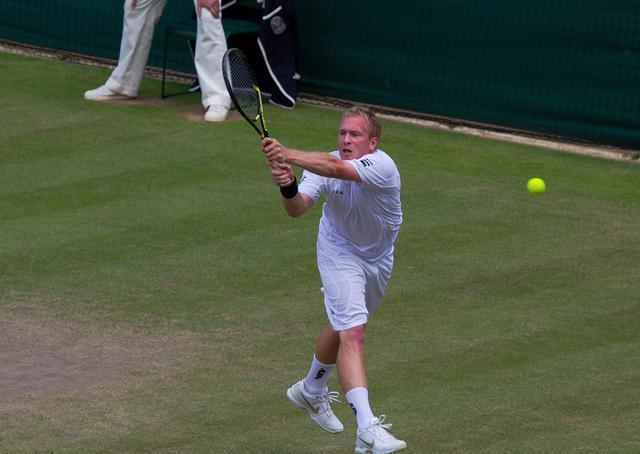What is the player ready to do?
Indicate the correct choice and explain in the format: 'Answer: answer
Rationale: rationale.'
Options: Sprint, bat, swing, dribble. Answer: swing.
Rationale: The person is holding a racket and a ball appears to be approaching which means they will likely have to perform answer a in accordance with the rules and purpose of the game. 